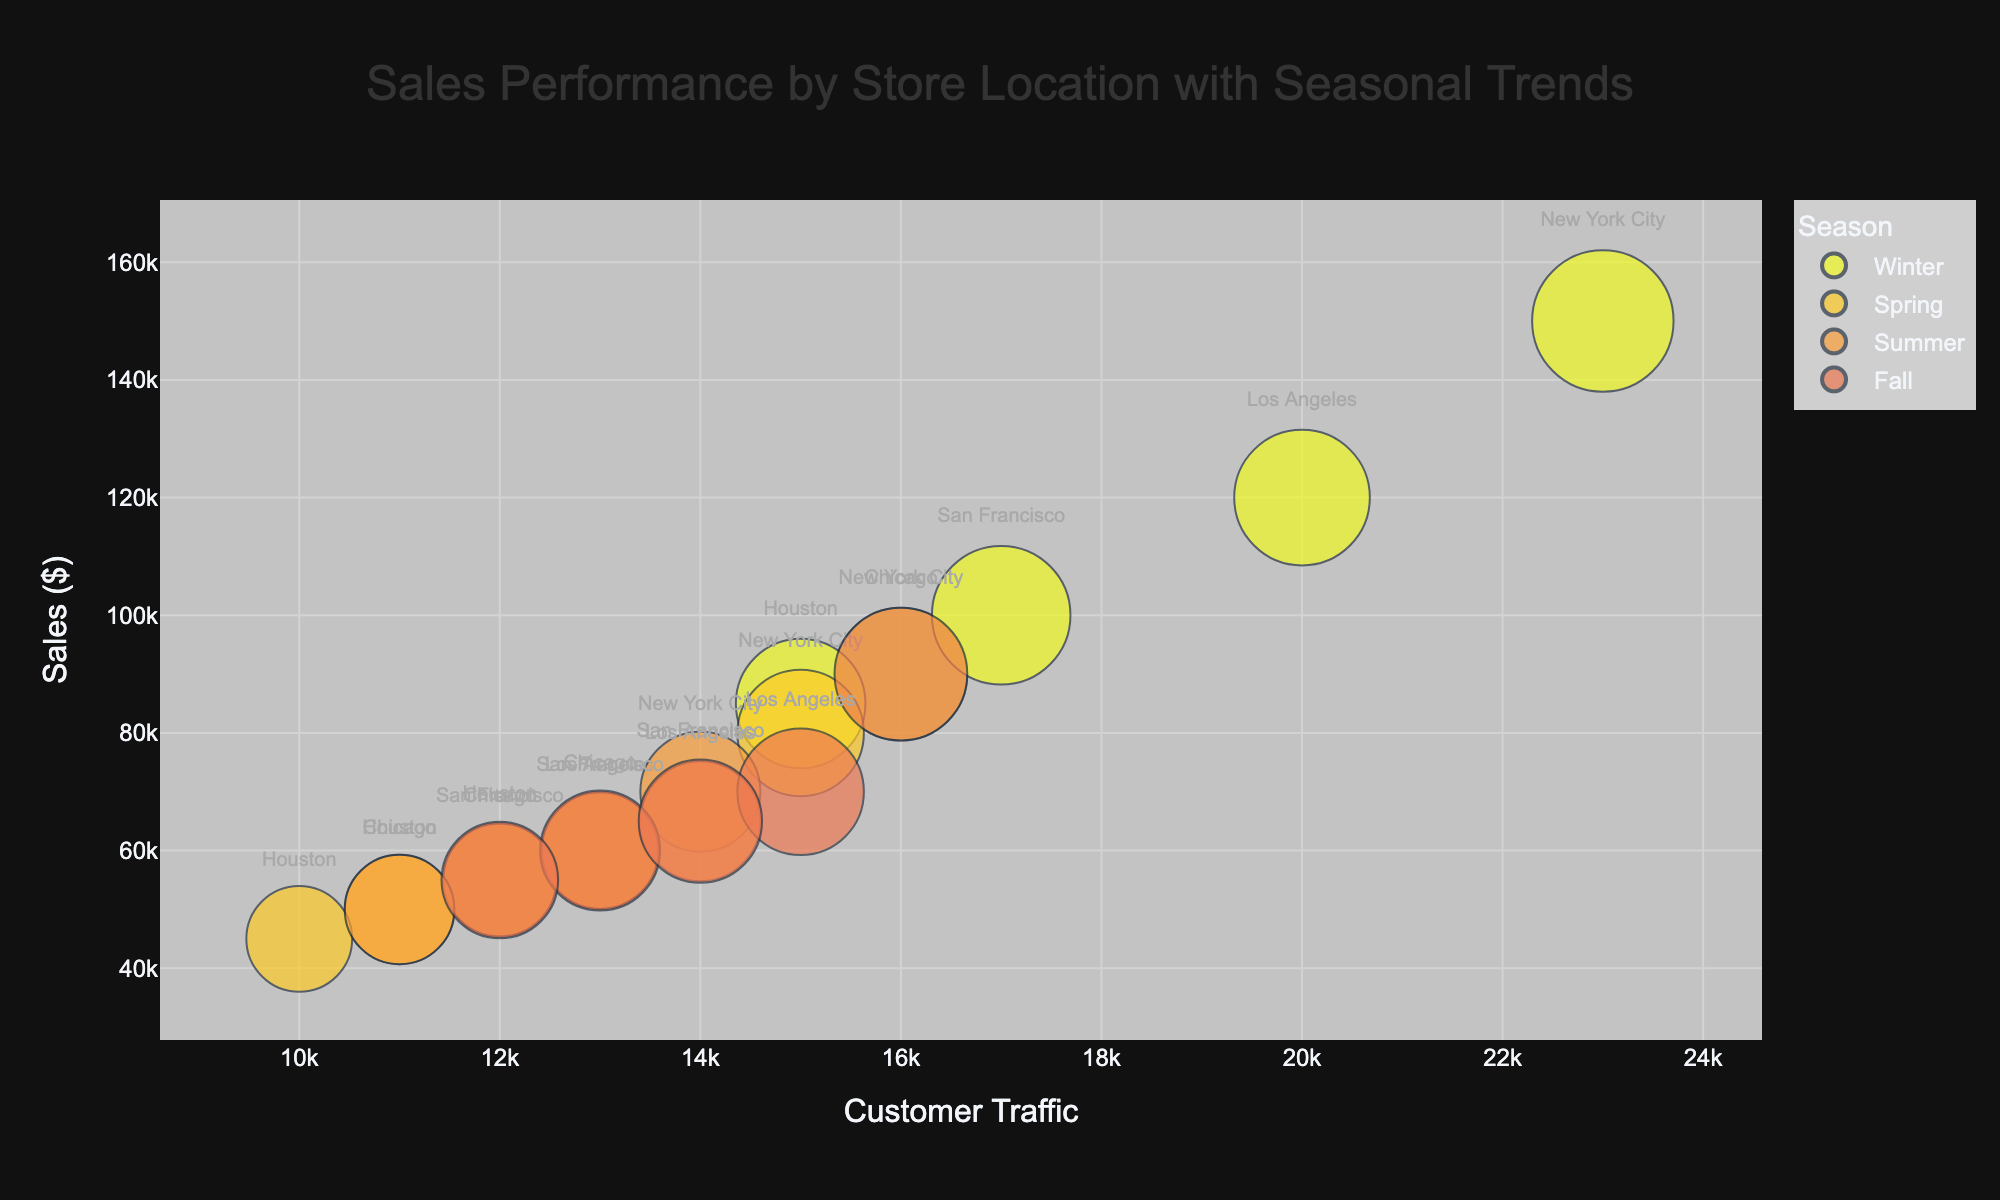How many store locations are represented in the figure? Count the unique store locations in the figure by checking the labels next to each data bubble: New York City, Los Angeles, Chicago, Houston, San Francisco.
Answer: 5 Which season has the highest sales in New York City? Identify which bubble labeled "New York City" is highest along the y-axis (Sales). In Winter, New York City reaches its peak sales of $150,000.
Answer: Winter What is the overall trend in profit margin across different seasons in New York City? Compare the size of the bubbles for New York City across different seasons. The bubble sizes, which represent profit margin, show a trend: Winter (25%), Spring (20%), Summer (18%), Fall (22%).
Answer: Winter > Spring > Fall > Summer Which store location has the highest customer traffic in the Winter season? Look for the bubble in the Winter season that is farthest to the right (represents highest customer traffic). New York City's bubble in Winter has the highest customer traffic at 23,000.
Answer: New York City How do the sales values compare between Los Angeles and San Francisco during the Summer season? Compare the positions of the bubbles for Los Angeles and San Francisco in the Summer season along the y-axis (Sales). Los Angeles: $65,000, San Francisco: $60,000.
Answer: Los Angeles > San Francisco Which store location has the smallest profit margin in the Spring season? Look at the bubbles for the Spring season and find the smallest one, representing the lowest profit margin. Houston's bubble in Spring has a profit margin of 14%.
Answer: Houston What is the average sales value for all stores in the Fall season? Add the sales values for all store locations during the Fall season and divide by the number of store locations: ($90,000 + $70,000 + $60,000 + $55,000 + $65,000) / 5 = $340,000 / 5 = $68,000.
Answer: $68,000 Is there a relationship between customer traffic and profit margin across all store locations? Examine if larger bubbles (higher profit margin) tend to be positioned more to the right (higher customer traffic). There is no consistent trend that higher customer traffic correlates with higher profit margins.
Answer: No consistent relationship Which season shows the largest range of sales values across all store locations? Calculate the range (difference between highest and lowest sales) for each season and compare: 
Winter: $150,000 - $85,000 = $65,000 
Spring: $80,000 - $45,000 = $35,000 
Summer: $70,000 - $50,000 = $20,000 
Fall: $90,000 - $55,000 = $35,000 
The Winter season has the largest range of $65,000.
Answer: Winter Which store location has the most balanced sales across all seasons? Check the store whose bubbles along the y-axis (Sales) are closest to each other: Los Angeles has sales values of $120,000, $60,000, $65,000, and $70,000, showing the least fluctuation overall.
Answer: Los Angeles 